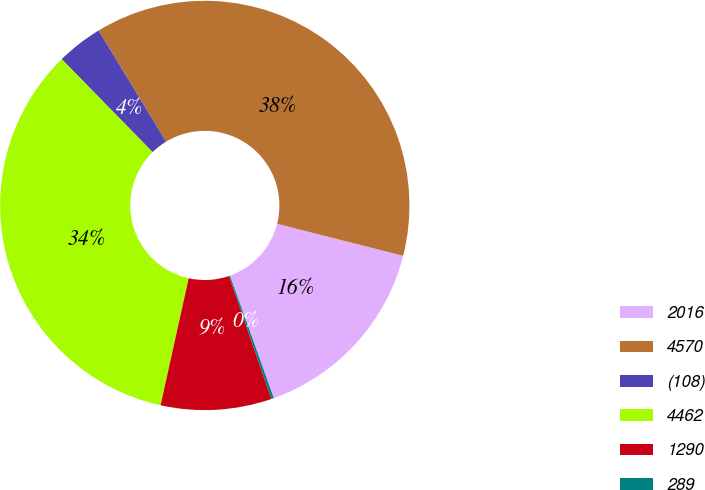Convert chart to OTSL. <chart><loc_0><loc_0><loc_500><loc_500><pie_chart><fcel>2016<fcel>4570<fcel>(108)<fcel>4462<fcel>1290<fcel>289<nl><fcel>15.57%<fcel>37.65%<fcel>3.64%<fcel>34.21%<fcel>8.74%<fcel>0.2%<nl></chart> 